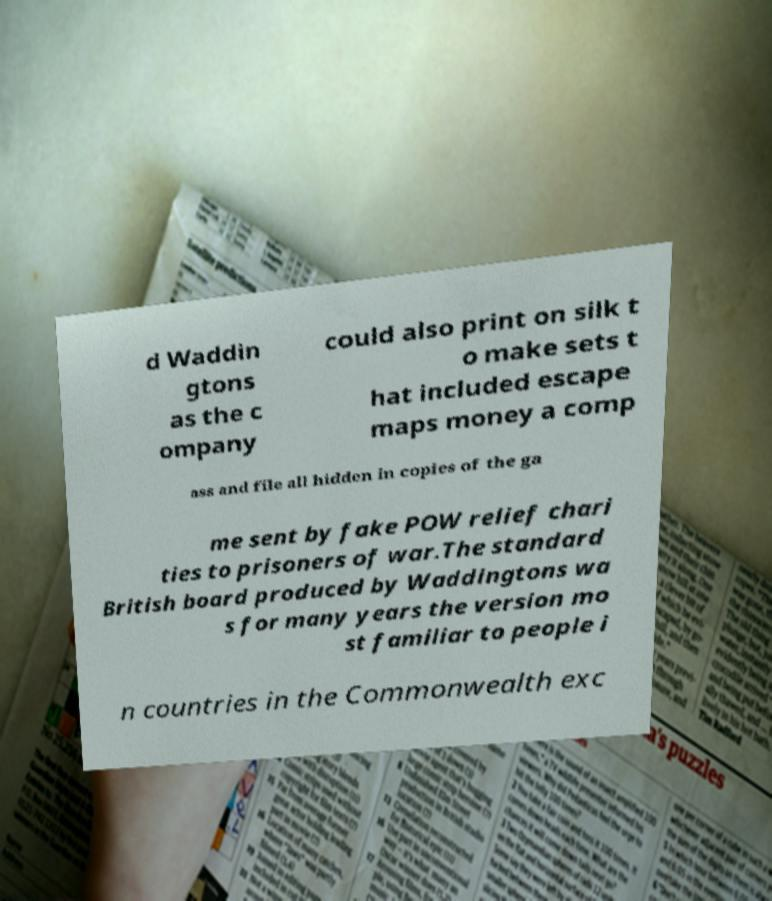Could you extract and type out the text from this image? d Waddin gtons as the c ompany could also print on silk t o make sets t hat included escape maps money a comp ass and file all hidden in copies of the ga me sent by fake POW relief chari ties to prisoners of war.The standard British board produced by Waddingtons wa s for many years the version mo st familiar to people i n countries in the Commonwealth exc 